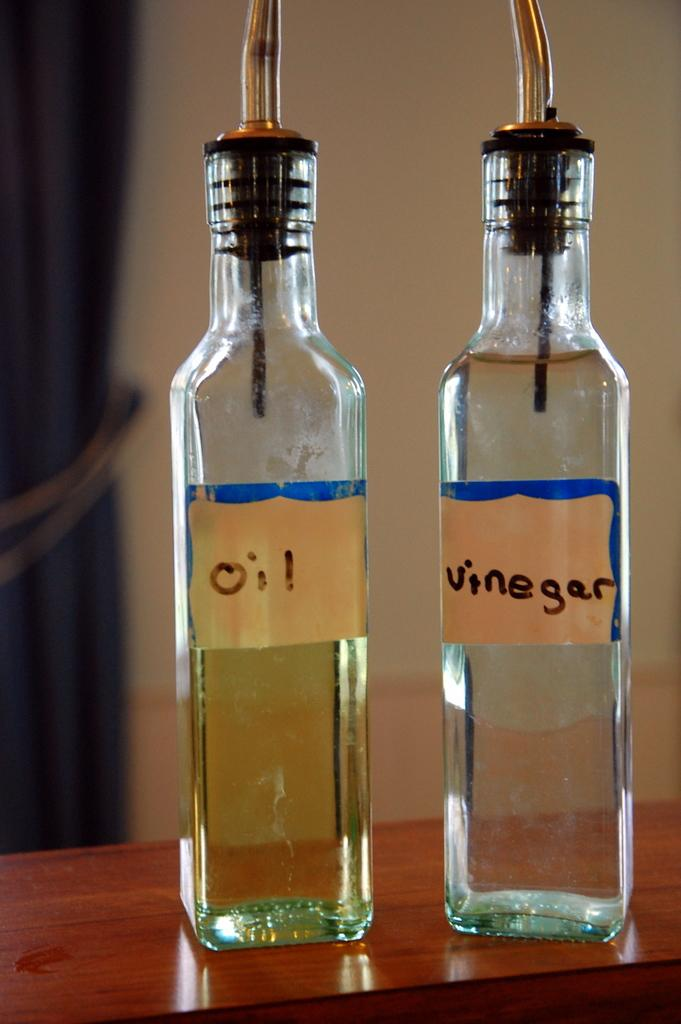<image>
Provide a brief description of the given image. Oil (on the left) and vinegar (on the right) are written on the labels of these two bottles. 